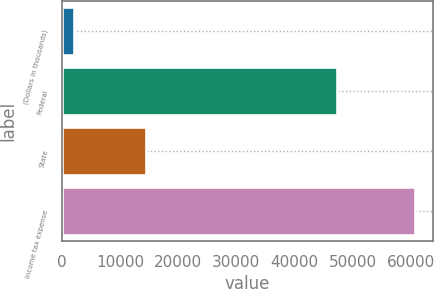Convert chart to OTSL. <chart><loc_0><loc_0><loc_500><loc_500><bar_chart><fcel>(Dollars in thousands)<fcel>Federal<fcel>State<fcel>Income tax expense<nl><fcel>2005<fcel>47353<fcel>14395<fcel>60758<nl></chart> 